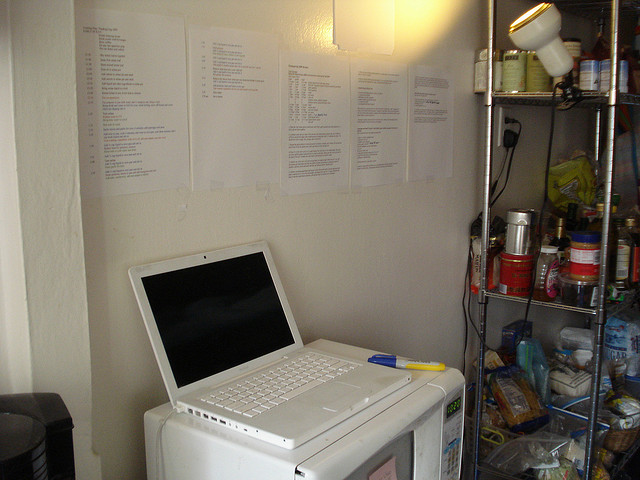Can you describe any electronic devices visible? Yes, the image contains a few electronic devices. Most notably, there's a white laptop on top of a microwave oven. Both devices appear to be in good working condition, indicating active use. Additionally, there is a coffee maker located at the bottom left of the image, suggesting that convenience and productivity are significant considerations in this space. 